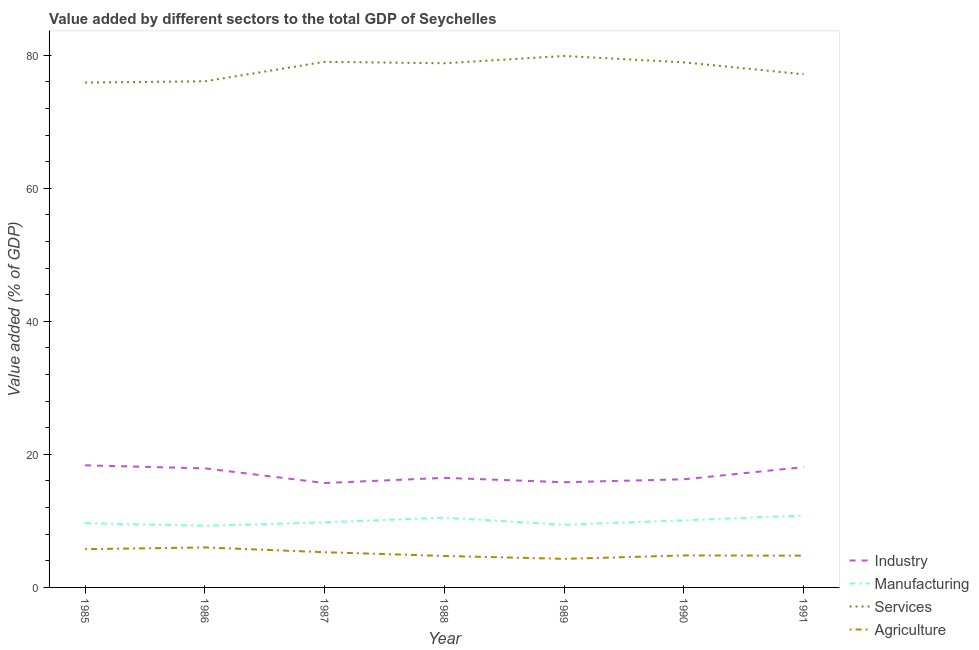Does the line corresponding to value added by industrial sector intersect with the line corresponding to value added by agricultural sector?
Keep it short and to the point. No. What is the value added by manufacturing sector in 1987?
Provide a succinct answer. 9.79. Across all years, what is the maximum value added by services sector?
Your answer should be very brief. 79.89. Across all years, what is the minimum value added by services sector?
Make the answer very short. 75.89. In which year was the value added by manufacturing sector maximum?
Give a very brief answer. 1991. What is the total value added by manufacturing sector in the graph?
Make the answer very short. 69.57. What is the difference between the value added by services sector in 1986 and that in 1988?
Make the answer very short. -2.71. What is the difference between the value added by manufacturing sector in 1986 and the value added by services sector in 1990?
Provide a succinct answer. -69.66. What is the average value added by industrial sector per year?
Offer a very short reply. 16.94. In the year 1990, what is the difference between the value added by industrial sector and value added by agricultural sector?
Provide a short and direct response. 11.45. In how many years, is the value added by services sector greater than 24 %?
Provide a short and direct response. 7. What is the ratio of the value added by manufacturing sector in 1989 to that in 1990?
Provide a short and direct response. 0.93. Is the difference between the value added by manufacturing sector in 1986 and 1988 greater than the difference between the value added by services sector in 1986 and 1988?
Your answer should be compact. Yes. What is the difference between the highest and the second highest value added by agricultural sector?
Ensure brevity in your answer.  0.26. What is the difference between the highest and the lowest value added by manufacturing sector?
Your answer should be very brief. 1.55. Is the sum of the value added by industrial sector in 1986 and 1988 greater than the maximum value added by manufacturing sector across all years?
Offer a very short reply. Yes. Is it the case that in every year, the sum of the value added by industrial sector and value added by manufacturing sector is greater than the value added by services sector?
Your answer should be very brief. No. Does the value added by industrial sector monotonically increase over the years?
Your response must be concise. No. Is the value added by industrial sector strictly greater than the value added by manufacturing sector over the years?
Keep it short and to the point. Yes. How many lines are there?
Ensure brevity in your answer.  4. Are the values on the major ticks of Y-axis written in scientific E-notation?
Your answer should be compact. No. Does the graph contain grids?
Keep it short and to the point. No. What is the title of the graph?
Provide a short and direct response. Value added by different sectors to the total GDP of Seychelles. Does "UNTA" appear as one of the legend labels in the graph?
Provide a succinct answer. No. What is the label or title of the X-axis?
Ensure brevity in your answer.  Year. What is the label or title of the Y-axis?
Provide a succinct answer. Value added (% of GDP). What is the Value added (% of GDP) of Industry in 1985?
Provide a short and direct response. 18.36. What is the Value added (% of GDP) of Manufacturing in 1985?
Give a very brief answer. 9.66. What is the Value added (% of GDP) in Services in 1985?
Your answer should be very brief. 75.89. What is the Value added (% of GDP) in Agriculture in 1985?
Your response must be concise. 5.75. What is the Value added (% of GDP) of Industry in 1986?
Keep it short and to the point. 17.9. What is the Value added (% of GDP) of Manufacturing in 1986?
Give a very brief answer. 9.27. What is the Value added (% of GDP) in Services in 1986?
Offer a terse response. 76.08. What is the Value added (% of GDP) of Agriculture in 1986?
Your response must be concise. 6.01. What is the Value added (% of GDP) of Industry in 1987?
Offer a terse response. 15.7. What is the Value added (% of GDP) of Manufacturing in 1987?
Ensure brevity in your answer.  9.79. What is the Value added (% of GDP) of Services in 1987?
Ensure brevity in your answer.  79.01. What is the Value added (% of GDP) in Agriculture in 1987?
Your response must be concise. 5.29. What is the Value added (% of GDP) in Industry in 1988?
Your response must be concise. 16.47. What is the Value added (% of GDP) in Manufacturing in 1988?
Ensure brevity in your answer.  10.5. What is the Value added (% of GDP) of Services in 1988?
Your answer should be very brief. 78.8. What is the Value added (% of GDP) of Agriculture in 1988?
Your answer should be compact. 4.73. What is the Value added (% of GDP) of Industry in 1989?
Your response must be concise. 15.82. What is the Value added (% of GDP) of Manufacturing in 1989?
Your response must be concise. 9.43. What is the Value added (% of GDP) of Services in 1989?
Your answer should be very brief. 79.89. What is the Value added (% of GDP) of Agriculture in 1989?
Offer a very short reply. 4.29. What is the Value added (% of GDP) in Industry in 1990?
Your answer should be compact. 16.26. What is the Value added (% of GDP) of Manufacturing in 1990?
Your answer should be compact. 10.1. What is the Value added (% of GDP) of Services in 1990?
Your answer should be very brief. 78.93. What is the Value added (% of GDP) of Agriculture in 1990?
Give a very brief answer. 4.81. What is the Value added (% of GDP) of Industry in 1991?
Make the answer very short. 18.08. What is the Value added (% of GDP) of Manufacturing in 1991?
Provide a succinct answer. 10.82. What is the Value added (% of GDP) in Services in 1991?
Make the answer very short. 77.14. What is the Value added (% of GDP) in Agriculture in 1991?
Your answer should be compact. 4.78. Across all years, what is the maximum Value added (% of GDP) of Industry?
Provide a succinct answer. 18.36. Across all years, what is the maximum Value added (% of GDP) in Manufacturing?
Your answer should be very brief. 10.82. Across all years, what is the maximum Value added (% of GDP) in Services?
Offer a terse response. 79.89. Across all years, what is the maximum Value added (% of GDP) of Agriculture?
Offer a terse response. 6.01. Across all years, what is the minimum Value added (% of GDP) in Industry?
Your answer should be compact. 15.7. Across all years, what is the minimum Value added (% of GDP) in Manufacturing?
Ensure brevity in your answer.  9.27. Across all years, what is the minimum Value added (% of GDP) in Services?
Make the answer very short. 75.89. Across all years, what is the minimum Value added (% of GDP) of Agriculture?
Provide a succinct answer. 4.29. What is the total Value added (% of GDP) in Industry in the graph?
Your answer should be compact. 118.58. What is the total Value added (% of GDP) in Manufacturing in the graph?
Give a very brief answer. 69.57. What is the total Value added (% of GDP) of Services in the graph?
Provide a succinct answer. 545.74. What is the total Value added (% of GDP) in Agriculture in the graph?
Provide a short and direct response. 35.67. What is the difference between the Value added (% of GDP) of Industry in 1985 and that in 1986?
Make the answer very short. 0.46. What is the difference between the Value added (% of GDP) of Manufacturing in 1985 and that in 1986?
Ensure brevity in your answer.  0.39. What is the difference between the Value added (% of GDP) in Services in 1985 and that in 1986?
Your response must be concise. -0.19. What is the difference between the Value added (% of GDP) in Agriculture in 1985 and that in 1986?
Your answer should be compact. -0.26. What is the difference between the Value added (% of GDP) of Industry in 1985 and that in 1987?
Your answer should be very brief. 2.66. What is the difference between the Value added (% of GDP) of Manufacturing in 1985 and that in 1987?
Give a very brief answer. -0.13. What is the difference between the Value added (% of GDP) in Services in 1985 and that in 1987?
Ensure brevity in your answer.  -3.12. What is the difference between the Value added (% of GDP) in Agriculture in 1985 and that in 1987?
Make the answer very short. 0.46. What is the difference between the Value added (% of GDP) in Industry in 1985 and that in 1988?
Give a very brief answer. 1.89. What is the difference between the Value added (% of GDP) in Manufacturing in 1985 and that in 1988?
Make the answer very short. -0.84. What is the difference between the Value added (% of GDP) in Services in 1985 and that in 1988?
Your answer should be very brief. -2.91. What is the difference between the Value added (% of GDP) of Agriculture in 1985 and that in 1988?
Provide a succinct answer. 1.02. What is the difference between the Value added (% of GDP) of Industry in 1985 and that in 1989?
Your answer should be compact. 2.54. What is the difference between the Value added (% of GDP) of Manufacturing in 1985 and that in 1989?
Ensure brevity in your answer.  0.23. What is the difference between the Value added (% of GDP) in Services in 1985 and that in 1989?
Make the answer very short. -4. What is the difference between the Value added (% of GDP) of Agriculture in 1985 and that in 1989?
Offer a very short reply. 1.46. What is the difference between the Value added (% of GDP) in Industry in 1985 and that in 1990?
Your answer should be compact. 2.1. What is the difference between the Value added (% of GDP) of Manufacturing in 1985 and that in 1990?
Your answer should be compact. -0.44. What is the difference between the Value added (% of GDP) of Services in 1985 and that in 1990?
Make the answer very short. -3.04. What is the difference between the Value added (% of GDP) of Agriculture in 1985 and that in 1990?
Make the answer very short. 0.94. What is the difference between the Value added (% of GDP) of Industry in 1985 and that in 1991?
Offer a very short reply. 0.27. What is the difference between the Value added (% of GDP) in Manufacturing in 1985 and that in 1991?
Your answer should be very brief. -1.16. What is the difference between the Value added (% of GDP) of Services in 1985 and that in 1991?
Your answer should be very brief. -1.25. What is the difference between the Value added (% of GDP) in Industry in 1986 and that in 1987?
Make the answer very short. 2.2. What is the difference between the Value added (% of GDP) in Manufacturing in 1986 and that in 1987?
Provide a short and direct response. -0.52. What is the difference between the Value added (% of GDP) of Services in 1986 and that in 1987?
Keep it short and to the point. -2.93. What is the difference between the Value added (% of GDP) of Agriculture in 1986 and that in 1987?
Your response must be concise. 0.72. What is the difference between the Value added (% of GDP) in Industry in 1986 and that in 1988?
Provide a succinct answer. 1.43. What is the difference between the Value added (% of GDP) of Manufacturing in 1986 and that in 1988?
Make the answer very short. -1.23. What is the difference between the Value added (% of GDP) of Services in 1986 and that in 1988?
Provide a succinct answer. -2.71. What is the difference between the Value added (% of GDP) of Agriculture in 1986 and that in 1988?
Offer a very short reply. 1.28. What is the difference between the Value added (% of GDP) of Industry in 1986 and that in 1989?
Give a very brief answer. 2.08. What is the difference between the Value added (% of GDP) of Manufacturing in 1986 and that in 1989?
Make the answer very short. -0.16. What is the difference between the Value added (% of GDP) in Services in 1986 and that in 1989?
Keep it short and to the point. -3.81. What is the difference between the Value added (% of GDP) of Agriculture in 1986 and that in 1989?
Give a very brief answer. 1.72. What is the difference between the Value added (% of GDP) of Industry in 1986 and that in 1990?
Offer a terse response. 1.64. What is the difference between the Value added (% of GDP) of Manufacturing in 1986 and that in 1990?
Ensure brevity in your answer.  -0.83. What is the difference between the Value added (% of GDP) in Services in 1986 and that in 1990?
Offer a very short reply. -2.85. What is the difference between the Value added (% of GDP) of Agriculture in 1986 and that in 1990?
Offer a very short reply. 1.2. What is the difference between the Value added (% of GDP) of Industry in 1986 and that in 1991?
Provide a succinct answer. -0.19. What is the difference between the Value added (% of GDP) in Manufacturing in 1986 and that in 1991?
Provide a short and direct response. -1.55. What is the difference between the Value added (% of GDP) in Services in 1986 and that in 1991?
Make the answer very short. -1.05. What is the difference between the Value added (% of GDP) of Agriculture in 1986 and that in 1991?
Make the answer very short. 1.24. What is the difference between the Value added (% of GDP) in Industry in 1987 and that in 1988?
Offer a terse response. -0.78. What is the difference between the Value added (% of GDP) in Manufacturing in 1987 and that in 1988?
Provide a short and direct response. -0.7. What is the difference between the Value added (% of GDP) in Services in 1987 and that in 1988?
Give a very brief answer. 0.21. What is the difference between the Value added (% of GDP) in Agriculture in 1987 and that in 1988?
Give a very brief answer. 0.56. What is the difference between the Value added (% of GDP) in Industry in 1987 and that in 1989?
Your response must be concise. -0.12. What is the difference between the Value added (% of GDP) of Manufacturing in 1987 and that in 1989?
Make the answer very short. 0.36. What is the difference between the Value added (% of GDP) in Services in 1987 and that in 1989?
Provide a succinct answer. -0.88. What is the difference between the Value added (% of GDP) in Agriculture in 1987 and that in 1989?
Your response must be concise. 1. What is the difference between the Value added (% of GDP) in Industry in 1987 and that in 1990?
Provide a succinct answer. -0.56. What is the difference between the Value added (% of GDP) of Manufacturing in 1987 and that in 1990?
Your answer should be compact. -0.3. What is the difference between the Value added (% of GDP) of Services in 1987 and that in 1990?
Ensure brevity in your answer.  0.08. What is the difference between the Value added (% of GDP) in Agriculture in 1987 and that in 1990?
Your response must be concise. 0.48. What is the difference between the Value added (% of GDP) of Industry in 1987 and that in 1991?
Your answer should be very brief. -2.39. What is the difference between the Value added (% of GDP) of Manufacturing in 1987 and that in 1991?
Keep it short and to the point. -1.03. What is the difference between the Value added (% of GDP) in Services in 1987 and that in 1991?
Ensure brevity in your answer.  1.87. What is the difference between the Value added (% of GDP) in Agriculture in 1987 and that in 1991?
Make the answer very short. 0.52. What is the difference between the Value added (% of GDP) of Industry in 1988 and that in 1989?
Make the answer very short. 0.66. What is the difference between the Value added (% of GDP) of Manufacturing in 1988 and that in 1989?
Your answer should be very brief. 1.07. What is the difference between the Value added (% of GDP) in Services in 1988 and that in 1989?
Your answer should be compact. -1.09. What is the difference between the Value added (% of GDP) of Agriculture in 1988 and that in 1989?
Give a very brief answer. 0.44. What is the difference between the Value added (% of GDP) in Industry in 1988 and that in 1990?
Give a very brief answer. 0.21. What is the difference between the Value added (% of GDP) of Manufacturing in 1988 and that in 1990?
Give a very brief answer. 0.4. What is the difference between the Value added (% of GDP) in Services in 1988 and that in 1990?
Your answer should be compact. -0.14. What is the difference between the Value added (% of GDP) in Agriculture in 1988 and that in 1990?
Provide a succinct answer. -0.08. What is the difference between the Value added (% of GDP) in Industry in 1988 and that in 1991?
Provide a succinct answer. -1.61. What is the difference between the Value added (% of GDP) of Manufacturing in 1988 and that in 1991?
Your response must be concise. -0.33. What is the difference between the Value added (% of GDP) in Services in 1988 and that in 1991?
Make the answer very short. 1.66. What is the difference between the Value added (% of GDP) in Agriculture in 1988 and that in 1991?
Give a very brief answer. -0.05. What is the difference between the Value added (% of GDP) of Industry in 1989 and that in 1990?
Provide a short and direct response. -0.44. What is the difference between the Value added (% of GDP) of Manufacturing in 1989 and that in 1990?
Offer a terse response. -0.67. What is the difference between the Value added (% of GDP) of Services in 1989 and that in 1990?
Offer a terse response. 0.96. What is the difference between the Value added (% of GDP) in Agriculture in 1989 and that in 1990?
Keep it short and to the point. -0.52. What is the difference between the Value added (% of GDP) of Industry in 1989 and that in 1991?
Offer a terse response. -2.27. What is the difference between the Value added (% of GDP) of Manufacturing in 1989 and that in 1991?
Make the answer very short. -1.39. What is the difference between the Value added (% of GDP) in Services in 1989 and that in 1991?
Make the answer very short. 2.75. What is the difference between the Value added (% of GDP) of Agriculture in 1989 and that in 1991?
Give a very brief answer. -0.48. What is the difference between the Value added (% of GDP) in Industry in 1990 and that in 1991?
Keep it short and to the point. -1.83. What is the difference between the Value added (% of GDP) of Manufacturing in 1990 and that in 1991?
Provide a succinct answer. -0.73. What is the difference between the Value added (% of GDP) in Services in 1990 and that in 1991?
Give a very brief answer. 1.8. What is the difference between the Value added (% of GDP) of Agriculture in 1990 and that in 1991?
Ensure brevity in your answer.  0.03. What is the difference between the Value added (% of GDP) of Industry in 1985 and the Value added (% of GDP) of Manufacturing in 1986?
Make the answer very short. 9.09. What is the difference between the Value added (% of GDP) in Industry in 1985 and the Value added (% of GDP) in Services in 1986?
Ensure brevity in your answer.  -57.73. What is the difference between the Value added (% of GDP) in Industry in 1985 and the Value added (% of GDP) in Agriculture in 1986?
Keep it short and to the point. 12.35. What is the difference between the Value added (% of GDP) of Manufacturing in 1985 and the Value added (% of GDP) of Services in 1986?
Your answer should be very brief. -66.42. What is the difference between the Value added (% of GDP) in Manufacturing in 1985 and the Value added (% of GDP) in Agriculture in 1986?
Make the answer very short. 3.65. What is the difference between the Value added (% of GDP) in Services in 1985 and the Value added (% of GDP) in Agriculture in 1986?
Make the answer very short. 69.88. What is the difference between the Value added (% of GDP) in Industry in 1985 and the Value added (% of GDP) in Manufacturing in 1987?
Keep it short and to the point. 8.57. What is the difference between the Value added (% of GDP) of Industry in 1985 and the Value added (% of GDP) of Services in 1987?
Offer a very short reply. -60.65. What is the difference between the Value added (% of GDP) in Industry in 1985 and the Value added (% of GDP) in Agriculture in 1987?
Ensure brevity in your answer.  13.06. What is the difference between the Value added (% of GDP) in Manufacturing in 1985 and the Value added (% of GDP) in Services in 1987?
Keep it short and to the point. -69.35. What is the difference between the Value added (% of GDP) of Manufacturing in 1985 and the Value added (% of GDP) of Agriculture in 1987?
Provide a succinct answer. 4.37. What is the difference between the Value added (% of GDP) of Services in 1985 and the Value added (% of GDP) of Agriculture in 1987?
Your answer should be very brief. 70.6. What is the difference between the Value added (% of GDP) in Industry in 1985 and the Value added (% of GDP) in Manufacturing in 1988?
Your answer should be very brief. 7.86. What is the difference between the Value added (% of GDP) in Industry in 1985 and the Value added (% of GDP) in Services in 1988?
Offer a very short reply. -60.44. What is the difference between the Value added (% of GDP) of Industry in 1985 and the Value added (% of GDP) of Agriculture in 1988?
Offer a terse response. 13.63. What is the difference between the Value added (% of GDP) of Manufacturing in 1985 and the Value added (% of GDP) of Services in 1988?
Ensure brevity in your answer.  -69.14. What is the difference between the Value added (% of GDP) in Manufacturing in 1985 and the Value added (% of GDP) in Agriculture in 1988?
Offer a very short reply. 4.93. What is the difference between the Value added (% of GDP) in Services in 1985 and the Value added (% of GDP) in Agriculture in 1988?
Provide a short and direct response. 71.16. What is the difference between the Value added (% of GDP) of Industry in 1985 and the Value added (% of GDP) of Manufacturing in 1989?
Offer a very short reply. 8.93. What is the difference between the Value added (% of GDP) in Industry in 1985 and the Value added (% of GDP) in Services in 1989?
Ensure brevity in your answer.  -61.53. What is the difference between the Value added (% of GDP) of Industry in 1985 and the Value added (% of GDP) of Agriculture in 1989?
Keep it short and to the point. 14.06. What is the difference between the Value added (% of GDP) of Manufacturing in 1985 and the Value added (% of GDP) of Services in 1989?
Your answer should be compact. -70.23. What is the difference between the Value added (% of GDP) in Manufacturing in 1985 and the Value added (% of GDP) in Agriculture in 1989?
Give a very brief answer. 5.37. What is the difference between the Value added (% of GDP) in Services in 1985 and the Value added (% of GDP) in Agriculture in 1989?
Ensure brevity in your answer.  71.6. What is the difference between the Value added (% of GDP) of Industry in 1985 and the Value added (% of GDP) of Manufacturing in 1990?
Keep it short and to the point. 8.26. What is the difference between the Value added (% of GDP) of Industry in 1985 and the Value added (% of GDP) of Services in 1990?
Your answer should be compact. -60.58. What is the difference between the Value added (% of GDP) in Industry in 1985 and the Value added (% of GDP) in Agriculture in 1990?
Provide a short and direct response. 13.55. What is the difference between the Value added (% of GDP) of Manufacturing in 1985 and the Value added (% of GDP) of Services in 1990?
Your response must be concise. -69.27. What is the difference between the Value added (% of GDP) of Manufacturing in 1985 and the Value added (% of GDP) of Agriculture in 1990?
Offer a very short reply. 4.85. What is the difference between the Value added (% of GDP) of Services in 1985 and the Value added (% of GDP) of Agriculture in 1990?
Give a very brief answer. 71.08. What is the difference between the Value added (% of GDP) in Industry in 1985 and the Value added (% of GDP) in Manufacturing in 1991?
Your answer should be compact. 7.54. What is the difference between the Value added (% of GDP) of Industry in 1985 and the Value added (% of GDP) of Services in 1991?
Give a very brief answer. -58.78. What is the difference between the Value added (% of GDP) in Industry in 1985 and the Value added (% of GDP) in Agriculture in 1991?
Keep it short and to the point. 13.58. What is the difference between the Value added (% of GDP) of Manufacturing in 1985 and the Value added (% of GDP) of Services in 1991?
Your response must be concise. -67.48. What is the difference between the Value added (% of GDP) of Manufacturing in 1985 and the Value added (% of GDP) of Agriculture in 1991?
Your answer should be very brief. 4.88. What is the difference between the Value added (% of GDP) in Services in 1985 and the Value added (% of GDP) in Agriculture in 1991?
Offer a terse response. 71.11. What is the difference between the Value added (% of GDP) in Industry in 1986 and the Value added (% of GDP) in Manufacturing in 1987?
Your answer should be compact. 8.11. What is the difference between the Value added (% of GDP) of Industry in 1986 and the Value added (% of GDP) of Services in 1987?
Offer a terse response. -61.11. What is the difference between the Value added (% of GDP) of Industry in 1986 and the Value added (% of GDP) of Agriculture in 1987?
Ensure brevity in your answer.  12.61. What is the difference between the Value added (% of GDP) of Manufacturing in 1986 and the Value added (% of GDP) of Services in 1987?
Ensure brevity in your answer.  -69.74. What is the difference between the Value added (% of GDP) in Manufacturing in 1986 and the Value added (% of GDP) in Agriculture in 1987?
Offer a very short reply. 3.97. What is the difference between the Value added (% of GDP) of Services in 1986 and the Value added (% of GDP) of Agriculture in 1987?
Offer a very short reply. 70.79. What is the difference between the Value added (% of GDP) in Industry in 1986 and the Value added (% of GDP) in Manufacturing in 1988?
Your answer should be compact. 7.4. What is the difference between the Value added (% of GDP) in Industry in 1986 and the Value added (% of GDP) in Services in 1988?
Keep it short and to the point. -60.9. What is the difference between the Value added (% of GDP) in Industry in 1986 and the Value added (% of GDP) in Agriculture in 1988?
Your answer should be very brief. 13.17. What is the difference between the Value added (% of GDP) of Manufacturing in 1986 and the Value added (% of GDP) of Services in 1988?
Make the answer very short. -69.53. What is the difference between the Value added (% of GDP) in Manufacturing in 1986 and the Value added (% of GDP) in Agriculture in 1988?
Make the answer very short. 4.54. What is the difference between the Value added (% of GDP) in Services in 1986 and the Value added (% of GDP) in Agriculture in 1988?
Ensure brevity in your answer.  71.35. What is the difference between the Value added (% of GDP) of Industry in 1986 and the Value added (% of GDP) of Manufacturing in 1989?
Ensure brevity in your answer.  8.47. What is the difference between the Value added (% of GDP) in Industry in 1986 and the Value added (% of GDP) in Services in 1989?
Your answer should be very brief. -61.99. What is the difference between the Value added (% of GDP) in Industry in 1986 and the Value added (% of GDP) in Agriculture in 1989?
Ensure brevity in your answer.  13.61. What is the difference between the Value added (% of GDP) of Manufacturing in 1986 and the Value added (% of GDP) of Services in 1989?
Offer a very short reply. -70.62. What is the difference between the Value added (% of GDP) of Manufacturing in 1986 and the Value added (% of GDP) of Agriculture in 1989?
Make the answer very short. 4.97. What is the difference between the Value added (% of GDP) of Services in 1986 and the Value added (% of GDP) of Agriculture in 1989?
Provide a succinct answer. 71.79. What is the difference between the Value added (% of GDP) of Industry in 1986 and the Value added (% of GDP) of Manufacturing in 1990?
Provide a short and direct response. 7.8. What is the difference between the Value added (% of GDP) in Industry in 1986 and the Value added (% of GDP) in Services in 1990?
Keep it short and to the point. -61.03. What is the difference between the Value added (% of GDP) of Industry in 1986 and the Value added (% of GDP) of Agriculture in 1990?
Keep it short and to the point. 13.09. What is the difference between the Value added (% of GDP) in Manufacturing in 1986 and the Value added (% of GDP) in Services in 1990?
Offer a terse response. -69.66. What is the difference between the Value added (% of GDP) in Manufacturing in 1986 and the Value added (% of GDP) in Agriculture in 1990?
Your answer should be very brief. 4.46. What is the difference between the Value added (% of GDP) of Services in 1986 and the Value added (% of GDP) of Agriculture in 1990?
Offer a terse response. 71.27. What is the difference between the Value added (% of GDP) in Industry in 1986 and the Value added (% of GDP) in Manufacturing in 1991?
Your answer should be compact. 7.08. What is the difference between the Value added (% of GDP) of Industry in 1986 and the Value added (% of GDP) of Services in 1991?
Provide a short and direct response. -59.24. What is the difference between the Value added (% of GDP) in Industry in 1986 and the Value added (% of GDP) in Agriculture in 1991?
Ensure brevity in your answer.  13.12. What is the difference between the Value added (% of GDP) of Manufacturing in 1986 and the Value added (% of GDP) of Services in 1991?
Provide a succinct answer. -67.87. What is the difference between the Value added (% of GDP) in Manufacturing in 1986 and the Value added (% of GDP) in Agriculture in 1991?
Your answer should be compact. 4.49. What is the difference between the Value added (% of GDP) of Services in 1986 and the Value added (% of GDP) of Agriculture in 1991?
Make the answer very short. 71.31. What is the difference between the Value added (% of GDP) in Industry in 1987 and the Value added (% of GDP) in Manufacturing in 1988?
Your answer should be very brief. 5.2. What is the difference between the Value added (% of GDP) of Industry in 1987 and the Value added (% of GDP) of Services in 1988?
Offer a very short reply. -63.1. What is the difference between the Value added (% of GDP) in Industry in 1987 and the Value added (% of GDP) in Agriculture in 1988?
Give a very brief answer. 10.96. What is the difference between the Value added (% of GDP) in Manufacturing in 1987 and the Value added (% of GDP) in Services in 1988?
Provide a succinct answer. -69. What is the difference between the Value added (% of GDP) in Manufacturing in 1987 and the Value added (% of GDP) in Agriculture in 1988?
Your answer should be compact. 5.06. What is the difference between the Value added (% of GDP) in Services in 1987 and the Value added (% of GDP) in Agriculture in 1988?
Give a very brief answer. 74.28. What is the difference between the Value added (% of GDP) of Industry in 1987 and the Value added (% of GDP) of Manufacturing in 1989?
Provide a short and direct response. 6.27. What is the difference between the Value added (% of GDP) of Industry in 1987 and the Value added (% of GDP) of Services in 1989?
Give a very brief answer. -64.19. What is the difference between the Value added (% of GDP) of Industry in 1987 and the Value added (% of GDP) of Agriculture in 1989?
Ensure brevity in your answer.  11.4. What is the difference between the Value added (% of GDP) in Manufacturing in 1987 and the Value added (% of GDP) in Services in 1989?
Offer a terse response. -70.1. What is the difference between the Value added (% of GDP) in Manufacturing in 1987 and the Value added (% of GDP) in Agriculture in 1989?
Ensure brevity in your answer.  5.5. What is the difference between the Value added (% of GDP) of Services in 1987 and the Value added (% of GDP) of Agriculture in 1989?
Ensure brevity in your answer.  74.72. What is the difference between the Value added (% of GDP) in Industry in 1987 and the Value added (% of GDP) in Manufacturing in 1990?
Keep it short and to the point. 5.6. What is the difference between the Value added (% of GDP) in Industry in 1987 and the Value added (% of GDP) in Services in 1990?
Provide a short and direct response. -63.24. What is the difference between the Value added (% of GDP) of Industry in 1987 and the Value added (% of GDP) of Agriculture in 1990?
Offer a very short reply. 10.89. What is the difference between the Value added (% of GDP) in Manufacturing in 1987 and the Value added (% of GDP) in Services in 1990?
Give a very brief answer. -69.14. What is the difference between the Value added (% of GDP) in Manufacturing in 1987 and the Value added (% of GDP) in Agriculture in 1990?
Your answer should be very brief. 4.98. What is the difference between the Value added (% of GDP) in Services in 1987 and the Value added (% of GDP) in Agriculture in 1990?
Your response must be concise. 74.2. What is the difference between the Value added (% of GDP) in Industry in 1987 and the Value added (% of GDP) in Manufacturing in 1991?
Ensure brevity in your answer.  4.87. What is the difference between the Value added (% of GDP) in Industry in 1987 and the Value added (% of GDP) in Services in 1991?
Offer a very short reply. -61.44. What is the difference between the Value added (% of GDP) in Industry in 1987 and the Value added (% of GDP) in Agriculture in 1991?
Your answer should be very brief. 10.92. What is the difference between the Value added (% of GDP) in Manufacturing in 1987 and the Value added (% of GDP) in Services in 1991?
Give a very brief answer. -67.34. What is the difference between the Value added (% of GDP) of Manufacturing in 1987 and the Value added (% of GDP) of Agriculture in 1991?
Your answer should be compact. 5.02. What is the difference between the Value added (% of GDP) of Services in 1987 and the Value added (% of GDP) of Agriculture in 1991?
Keep it short and to the point. 74.23. What is the difference between the Value added (% of GDP) of Industry in 1988 and the Value added (% of GDP) of Manufacturing in 1989?
Make the answer very short. 7.04. What is the difference between the Value added (% of GDP) of Industry in 1988 and the Value added (% of GDP) of Services in 1989?
Keep it short and to the point. -63.42. What is the difference between the Value added (% of GDP) in Industry in 1988 and the Value added (% of GDP) in Agriculture in 1989?
Offer a terse response. 12.18. What is the difference between the Value added (% of GDP) in Manufacturing in 1988 and the Value added (% of GDP) in Services in 1989?
Offer a terse response. -69.39. What is the difference between the Value added (% of GDP) in Manufacturing in 1988 and the Value added (% of GDP) in Agriculture in 1989?
Your response must be concise. 6.2. What is the difference between the Value added (% of GDP) of Services in 1988 and the Value added (% of GDP) of Agriculture in 1989?
Keep it short and to the point. 74.5. What is the difference between the Value added (% of GDP) of Industry in 1988 and the Value added (% of GDP) of Manufacturing in 1990?
Make the answer very short. 6.38. What is the difference between the Value added (% of GDP) in Industry in 1988 and the Value added (% of GDP) in Services in 1990?
Make the answer very short. -62.46. What is the difference between the Value added (% of GDP) in Industry in 1988 and the Value added (% of GDP) in Agriculture in 1990?
Your answer should be very brief. 11.66. What is the difference between the Value added (% of GDP) in Manufacturing in 1988 and the Value added (% of GDP) in Services in 1990?
Give a very brief answer. -68.44. What is the difference between the Value added (% of GDP) of Manufacturing in 1988 and the Value added (% of GDP) of Agriculture in 1990?
Give a very brief answer. 5.69. What is the difference between the Value added (% of GDP) in Services in 1988 and the Value added (% of GDP) in Agriculture in 1990?
Your answer should be very brief. 73.99. What is the difference between the Value added (% of GDP) in Industry in 1988 and the Value added (% of GDP) in Manufacturing in 1991?
Ensure brevity in your answer.  5.65. What is the difference between the Value added (% of GDP) of Industry in 1988 and the Value added (% of GDP) of Services in 1991?
Provide a succinct answer. -60.67. What is the difference between the Value added (% of GDP) in Industry in 1988 and the Value added (% of GDP) in Agriculture in 1991?
Your answer should be compact. 11.69. What is the difference between the Value added (% of GDP) of Manufacturing in 1988 and the Value added (% of GDP) of Services in 1991?
Keep it short and to the point. -66.64. What is the difference between the Value added (% of GDP) of Manufacturing in 1988 and the Value added (% of GDP) of Agriculture in 1991?
Offer a terse response. 5.72. What is the difference between the Value added (% of GDP) in Services in 1988 and the Value added (% of GDP) in Agriculture in 1991?
Make the answer very short. 74.02. What is the difference between the Value added (% of GDP) in Industry in 1989 and the Value added (% of GDP) in Manufacturing in 1990?
Offer a very short reply. 5.72. What is the difference between the Value added (% of GDP) in Industry in 1989 and the Value added (% of GDP) in Services in 1990?
Offer a very short reply. -63.12. What is the difference between the Value added (% of GDP) in Industry in 1989 and the Value added (% of GDP) in Agriculture in 1990?
Your answer should be compact. 11.01. What is the difference between the Value added (% of GDP) in Manufacturing in 1989 and the Value added (% of GDP) in Services in 1990?
Provide a short and direct response. -69.5. What is the difference between the Value added (% of GDP) of Manufacturing in 1989 and the Value added (% of GDP) of Agriculture in 1990?
Offer a very short reply. 4.62. What is the difference between the Value added (% of GDP) in Services in 1989 and the Value added (% of GDP) in Agriculture in 1990?
Your answer should be very brief. 75.08. What is the difference between the Value added (% of GDP) in Industry in 1989 and the Value added (% of GDP) in Manufacturing in 1991?
Provide a short and direct response. 4.99. What is the difference between the Value added (% of GDP) in Industry in 1989 and the Value added (% of GDP) in Services in 1991?
Your response must be concise. -61.32. What is the difference between the Value added (% of GDP) in Industry in 1989 and the Value added (% of GDP) in Agriculture in 1991?
Offer a terse response. 11.04. What is the difference between the Value added (% of GDP) in Manufacturing in 1989 and the Value added (% of GDP) in Services in 1991?
Your answer should be compact. -67.71. What is the difference between the Value added (% of GDP) in Manufacturing in 1989 and the Value added (% of GDP) in Agriculture in 1991?
Your answer should be compact. 4.65. What is the difference between the Value added (% of GDP) of Services in 1989 and the Value added (% of GDP) of Agriculture in 1991?
Ensure brevity in your answer.  75.11. What is the difference between the Value added (% of GDP) of Industry in 1990 and the Value added (% of GDP) of Manufacturing in 1991?
Offer a terse response. 5.43. What is the difference between the Value added (% of GDP) of Industry in 1990 and the Value added (% of GDP) of Services in 1991?
Ensure brevity in your answer.  -60.88. What is the difference between the Value added (% of GDP) of Industry in 1990 and the Value added (% of GDP) of Agriculture in 1991?
Your answer should be very brief. 11.48. What is the difference between the Value added (% of GDP) in Manufacturing in 1990 and the Value added (% of GDP) in Services in 1991?
Offer a terse response. -67.04. What is the difference between the Value added (% of GDP) of Manufacturing in 1990 and the Value added (% of GDP) of Agriculture in 1991?
Your response must be concise. 5.32. What is the difference between the Value added (% of GDP) in Services in 1990 and the Value added (% of GDP) in Agriculture in 1991?
Offer a terse response. 74.16. What is the average Value added (% of GDP) of Industry per year?
Give a very brief answer. 16.94. What is the average Value added (% of GDP) of Manufacturing per year?
Offer a terse response. 9.94. What is the average Value added (% of GDP) in Services per year?
Your answer should be very brief. 77.96. What is the average Value added (% of GDP) in Agriculture per year?
Provide a short and direct response. 5.1. In the year 1985, what is the difference between the Value added (% of GDP) of Industry and Value added (% of GDP) of Manufacturing?
Offer a very short reply. 8.7. In the year 1985, what is the difference between the Value added (% of GDP) of Industry and Value added (% of GDP) of Services?
Ensure brevity in your answer.  -57.53. In the year 1985, what is the difference between the Value added (% of GDP) of Industry and Value added (% of GDP) of Agriculture?
Your response must be concise. 12.61. In the year 1985, what is the difference between the Value added (% of GDP) of Manufacturing and Value added (% of GDP) of Services?
Offer a very short reply. -66.23. In the year 1985, what is the difference between the Value added (% of GDP) of Manufacturing and Value added (% of GDP) of Agriculture?
Provide a short and direct response. 3.91. In the year 1985, what is the difference between the Value added (% of GDP) of Services and Value added (% of GDP) of Agriculture?
Your answer should be compact. 70.14. In the year 1986, what is the difference between the Value added (% of GDP) of Industry and Value added (% of GDP) of Manufacturing?
Offer a terse response. 8.63. In the year 1986, what is the difference between the Value added (% of GDP) of Industry and Value added (% of GDP) of Services?
Your response must be concise. -58.18. In the year 1986, what is the difference between the Value added (% of GDP) of Industry and Value added (% of GDP) of Agriculture?
Your answer should be compact. 11.89. In the year 1986, what is the difference between the Value added (% of GDP) of Manufacturing and Value added (% of GDP) of Services?
Your response must be concise. -66.81. In the year 1986, what is the difference between the Value added (% of GDP) in Manufacturing and Value added (% of GDP) in Agriculture?
Your answer should be very brief. 3.26. In the year 1986, what is the difference between the Value added (% of GDP) in Services and Value added (% of GDP) in Agriculture?
Your response must be concise. 70.07. In the year 1987, what is the difference between the Value added (% of GDP) of Industry and Value added (% of GDP) of Manufacturing?
Provide a short and direct response. 5.9. In the year 1987, what is the difference between the Value added (% of GDP) in Industry and Value added (% of GDP) in Services?
Keep it short and to the point. -63.31. In the year 1987, what is the difference between the Value added (% of GDP) in Industry and Value added (% of GDP) in Agriculture?
Your response must be concise. 10.4. In the year 1987, what is the difference between the Value added (% of GDP) of Manufacturing and Value added (% of GDP) of Services?
Keep it short and to the point. -69.22. In the year 1987, what is the difference between the Value added (% of GDP) of Manufacturing and Value added (% of GDP) of Agriculture?
Provide a succinct answer. 4.5. In the year 1987, what is the difference between the Value added (% of GDP) in Services and Value added (% of GDP) in Agriculture?
Make the answer very short. 73.72. In the year 1988, what is the difference between the Value added (% of GDP) of Industry and Value added (% of GDP) of Manufacturing?
Offer a very short reply. 5.98. In the year 1988, what is the difference between the Value added (% of GDP) of Industry and Value added (% of GDP) of Services?
Provide a succinct answer. -62.32. In the year 1988, what is the difference between the Value added (% of GDP) of Industry and Value added (% of GDP) of Agriculture?
Your answer should be very brief. 11.74. In the year 1988, what is the difference between the Value added (% of GDP) of Manufacturing and Value added (% of GDP) of Services?
Make the answer very short. -68.3. In the year 1988, what is the difference between the Value added (% of GDP) of Manufacturing and Value added (% of GDP) of Agriculture?
Offer a terse response. 5.77. In the year 1988, what is the difference between the Value added (% of GDP) of Services and Value added (% of GDP) of Agriculture?
Ensure brevity in your answer.  74.06. In the year 1989, what is the difference between the Value added (% of GDP) of Industry and Value added (% of GDP) of Manufacturing?
Your answer should be compact. 6.39. In the year 1989, what is the difference between the Value added (% of GDP) in Industry and Value added (% of GDP) in Services?
Give a very brief answer. -64.07. In the year 1989, what is the difference between the Value added (% of GDP) in Industry and Value added (% of GDP) in Agriculture?
Ensure brevity in your answer.  11.52. In the year 1989, what is the difference between the Value added (% of GDP) in Manufacturing and Value added (% of GDP) in Services?
Keep it short and to the point. -70.46. In the year 1989, what is the difference between the Value added (% of GDP) in Manufacturing and Value added (% of GDP) in Agriculture?
Keep it short and to the point. 5.14. In the year 1989, what is the difference between the Value added (% of GDP) in Services and Value added (% of GDP) in Agriculture?
Your response must be concise. 75.6. In the year 1990, what is the difference between the Value added (% of GDP) of Industry and Value added (% of GDP) of Manufacturing?
Your response must be concise. 6.16. In the year 1990, what is the difference between the Value added (% of GDP) of Industry and Value added (% of GDP) of Services?
Offer a terse response. -62.68. In the year 1990, what is the difference between the Value added (% of GDP) of Industry and Value added (% of GDP) of Agriculture?
Ensure brevity in your answer.  11.45. In the year 1990, what is the difference between the Value added (% of GDP) of Manufacturing and Value added (% of GDP) of Services?
Keep it short and to the point. -68.84. In the year 1990, what is the difference between the Value added (% of GDP) of Manufacturing and Value added (% of GDP) of Agriculture?
Your response must be concise. 5.29. In the year 1990, what is the difference between the Value added (% of GDP) of Services and Value added (% of GDP) of Agriculture?
Provide a short and direct response. 74.12. In the year 1991, what is the difference between the Value added (% of GDP) of Industry and Value added (% of GDP) of Manufacturing?
Offer a terse response. 7.26. In the year 1991, what is the difference between the Value added (% of GDP) in Industry and Value added (% of GDP) in Services?
Offer a very short reply. -59.05. In the year 1991, what is the difference between the Value added (% of GDP) of Industry and Value added (% of GDP) of Agriculture?
Keep it short and to the point. 13.31. In the year 1991, what is the difference between the Value added (% of GDP) of Manufacturing and Value added (% of GDP) of Services?
Keep it short and to the point. -66.31. In the year 1991, what is the difference between the Value added (% of GDP) in Manufacturing and Value added (% of GDP) in Agriculture?
Keep it short and to the point. 6.05. In the year 1991, what is the difference between the Value added (% of GDP) of Services and Value added (% of GDP) of Agriculture?
Your response must be concise. 72.36. What is the ratio of the Value added (% of GDP) of Industry in 1985 to that in 1986?
Your response must be concise. 1.03. What is the ratio of the Value added (% of GDP) in Manufacturing in 1985 to that in 1986?
Your response must be concise. 1.04. What is the ratio of the Value added (% of GDP) in Services in 1985 to that in 1986?
Keep it short and to the point. 1. What is the ratio of the Value added (% of GDP) in Agriculture in 1985 to that in 1986?
Keep it short and to the point. 0.96. What is the ratio of the Value added (% of GDP) in Industry in 1985 to that in 1987?
Offer a very short reply. 1.17. What is the ratio of the Value added (% of GDP) of Manufacturing in 1985 to that in 1987?
Your answer should be very brief. 0.99. What is the ratio of the Value added (% of GDP) of Services in 1985 to that in 1987?
Provide a short and direct response. 0.96. What is the ratio of the Value added (% of GDP) in Agriculture in 1985 to that in 1987?
Provide a short and direct response. 1.09. What is the ratio of the Value added (% of GDP) of Industry in 1985 to that in 1988?
Keep it short and to the point. 1.11. What is the ratio of the Value added (% of GDP) in Manufacturing in 1985 to that in 1988?
Your answer should be compact. 0.92. What is the ratio of the Value added (% of GDP) in Services in 1985 to that in 1988?
Your answer should be very brief. 0.96. What is the ratio of the Value added (% of GDP) of Agriculture in 1985 to that in 1988?
Offer a terse response. 1.22. What is the ratio of the Value added (% of GDP) in Industry in 1985 to that in 1989?
Your response must be concise. 1.16. What is the ratio of the Value added (% of GDP) in Manufacturing in 1985 to that in 1989?
Give a very brief answer. 1.02. What is the ratio of the Value added (% of GDP) in Services in 1985 to that in 1989?
Keep it short and to the point. 0.95. What is the ratio of the Value added (% of GDP) of Agriculture in 1985 to that in 1989?
Make the answer very short. 1.34. What is the ratio of the Value added (% of GDP) of Industry in 1985 to that in 1990?
Provide a short and direct response. 1.13. What is the ratio of the Value added (% of GDP) of Manufacturing in 1985 to that in 1990?
Offer a terse response. 0.96. What is the ratio of the Value added (% of GDP) in Services in 1985 to that in 1990?
Provide a short and direct response. 0.96. What is the ratio of the Value added (% of GDP) of Agriculture in 1985 to that in 1990?
Provide a short and direct response. 1.2. What is the ratio of the Value added (% of GDP) of Industry in 1985 to that in 1991?
Provide a succinct answer. 1.02. What is the ratio of the Value added (% of GDP) of Manufacturing in 1985 to that in 1991?
Make the answer very short. 0.89. What is the ratio of the Value added (% of GDP) in Services in 1985 to that in 1991?
Offer a very short reply. 0.98. What is the ratio of the Value added (% of GDP) of Agriculture in 1985 to that in 1991?
Offer a very short reply. 1.2. What is the ratio of the Value added (% of GDP) in Industry in 1986 to that in 1987?
Your answer should be compact. 1.14. What is the ratio of the Value added (% of GDP) in Manufacturing in 1986 to that in 1987?
Make the answer very short. 0.95. What is the ratio of the Value added (% of GDP) of Services in 1986 to that in 1987?
Provide a succinct answer. 0.96. What is the ratio of the Value added (% of GDP) in Agriculture in 1986 to that in 1987?
Offer a terse response. 1.14. What is the ratio of the Value added (% of GDP) in Industry in 1986 to that in 1988?
Offer a very short reply. 1.09. What is the ratio of the Value added (% of GDP) of Manufacturing in 1986 to that in 1988?
Ensure brevity in your answer.  0.88. What is the ratio of the Value added (% of GDP) in Services in 1986 to that in 1988?
Provide a succinct answer. 0.97. What is the ratio of the Value added (% of GDP) of Agriculture in 1986 to that in 1988?
Offer a very short reply. 1.27. What is the ratio of the Value added (% of GDP) in Industry in 1986 to that in 1989?
Your answer should be compact. 1.13. What is the ratio of the Value added (% of GDP) of Manufacturing in 1986 to that in 1989?
Keep it short and to the point. 0.98. What is the ratio of the Value added (% of GDP) in Agriculture in 1986 to that in 1989?
Provide a short and direct response. 1.4. What is the ratio of the Value added (% of GDP) of Industry in 1986 to that in 1990?
Give a very brief answer. 1.1. What is the ratio of the Value added (% of GDP) of Manufacturing in 1986 to that in 1990?
Keep it short and to the point. 0.92. What is the ratio of the Value added (% of GDP) in Services in 1986 to that in 1990?
Your answer should be compact. 0.96. What is the ratio of the Value added (% of GDP) of Agriculture in 1986 to that in 1990?
Ensure brevity in your answer.  1.25. What is the ratio of the Value added (% of GDP) in Industry in 1986 to that in 1991?
Your answer should be compact. 0.99. What is the ratio of the Value added (% of GDP) of Manufacturing in 1986 to that in 1991?
Offer a terse response. 0.86. What is the ratio of the Value added (% of GDP) of Services in 1986 to that in 1991?
Your answer should be very brief. 0.99. What is the ratio of the Value added (% of GDP) in Agriculture in 1986 to that in 1991?
Ensure brevity in your answer.  1.26. What is the ratio of the Value added (% of GDP) in Industry in 1987 to that in 1988?
Provide a short and direct response. 0.95. What is the ratio of the Value added (% of GDP) of Manufacturing in 1987 to that in 1988?
Your answer should be very brief. 0.93. What is the ratio of the Value added (% of GDP) in Agriculture in 1987 to that in 1988?
Offer a terse response. 1.12. What is the ratio of the Value added (% of GDP) in Industry in 1987 to that in 1989?
Provide a short and direct response. 0.99. What is the ratio of the Value added (% of GDP) in Manufacturing in 1987 to that in 1989?
Provide a short and direct response. 1.04. What is the ratio of the Value added (% of GDP) of Services in 1987 to that in 1989?
Provide a short and direct response. 0.99. What is the ratio of the Value added (% of GDP) of Agriculture in 1987 to that in 1989?
Your answer should be compact. 1.23. What is the ratio of the Value added (% of GDP) of Industry in 1987 to that in 1990?
Make the answer very short. 0.97. What is the ratio of the Value added (% of GDP) in Manufacturing in 1987 to that in 1990?
Give a very brief answer. 0.97. What is the ratio of the Value added (% of GDP) of Agriculture in 1987 to that in 1990?
Provide a short and direct response. 1.1. What is the ratio of the Value added (% of GDP) of Industry in 1987 to that in 1991?
Your response must be concise. 0.87. What is the ratio of the Value added (% of GDP) in Manufacturing in 1987 to that in 1991?
Your response must be concise. 0.9. What is the ratio of the Value added (% of GDP) in Services in 1987 to that in 1991?
Offer a very short reply. 1.02. What is the ratio of the Value added (% of GDP) of Agriculture in 1987 to that in 1991?
Offer a terse response. 1.11. What is the ratio of the Value added (% of GDP) of Industry in 1988 to that in 1989?
Make the answer very short. 1.04. What is the ratio of the Value added (% of GDP) in Manufacturing in 1988 to that in 1989?
Offer a very short reply. 1.11. What is the ratio of the Value added (% of GDP) of Services in 1988 to that in 1989?
Provide a succinct answer. 0.99. What is the ratio of the Value added (% of GDP) of Agriculture in 1988 to that in 1989?
Offer a very short reply. 1.1. What is the ratio of the Value added (% of GDP) of Industry in 1988 to that in 1990?
Offer a terse response. 1.01. What is the ratio of the Value added (% of GDP) in Manufacturing in 1988 to that in 1990?
Keep it short and to the point. 1.04. What is the ratio of the Value added (% of GDP) in Services in 1988 to that in 1990?
Provide a short and direct response. 1. What is the ratio of the Value added (% of GDP) in Agriculture in 1988 to that in 1990?
Your answer should be compact. 0.98. What is the ratio of the Value added (% of GDP) of Industry in 1988 to that in 1991?
Your answer should be very brief. 0.91. What is the ratio of the Value added (% of GDP) in Manufacturing in 1988 to that in 1991?
Ensure brevity in your answer.  0.97. What is the ratio of the Value added (% of GDP) of Services in 1988 to that in 1991?
Provide a short and direct response. 1.02. What is the ratio of the Value added (% of GDP) of Industry in 1989 to that in 1990?
Give a very brief answer. 0.97. What is the ratio of the Value added (% of GDP) in Manufacturing in 1989 to that in 1990?
Your answer should be compact. 0.93. What is the ratio of the Value added (% of GDP) of Services in 1989 to that in 1990?
Your answer should be very brief. 1.01. What is the ratio of the Value added (% of GDP) in Agriculture in 1989 to that in 1990?
Your answer should be compact. 0.89. What is the ratio of the Value added (% of GDP) of Industry in 1989 to that in 1991?
Offer a very short reply. 0.87. What is the ratio of the Value added (% of GDP) in Manufacturing in 1989 to that in 1991?
Provide a succinct answer. 0.87. What is the ratio of the Value added (% of GDP) in Services in 1989 to that in 1991?
Offer a very short reply. 1.04. What is the ratio of the Value added (% of GDP) of Agriculture in 1989 to that in 1991?
Make the answer very short. 0.9. What is the ratio of the Value added (% of GDP) of Industry in 1990 to that in 1991?
Provide a short and direct response. 0.9. What is the ratio of the Value added (% of GDP) of Manufacturing in 1990 to that in 1991?
Your response must be concise. 0.93. What is the ratio of the Value added (% of GDP) of Services in 1990 to that in 1991?
Offer a very short reply. 1.02. What is the ratio of the Value added (% of GDP) in Agriculture in 1990 to that in 1991?
Your answer should be very brief. 1.01. What is the difference between the highest and the second highest Value added (% of GDP) in Industry?
Your answer should be very brief. 0.27. What is the difference between the highest and the second highest Value added (% of GDP) in Manufacturing?
Provide a succinct answer. 0.33. What is the difference between the highest and the second highest Value added (% of GDP) of Services?
Ensure brevity in your answer.  0.88. What is the difference between the highest and the second highest Value added (% of GDP) of Agriculture?
Offer a very short reply. 0.26. What is the difference between the highest and the lowest Value added (% of GDP) of Industry?
Provide a short and direct response. 2.66. What is the difference between the highest and the lowest Value added (% of GDP) in Manufacturing?
Keep it short and to the point. 1.55. What is the difference between the highest and the lowest Value added (% of GDP) in Services?
Keep it short and to the point. 4. What is the difference between the highest and the lowest Value added (% of GDP) in Agriculture?
Keep it short and to the point. 1.72. 